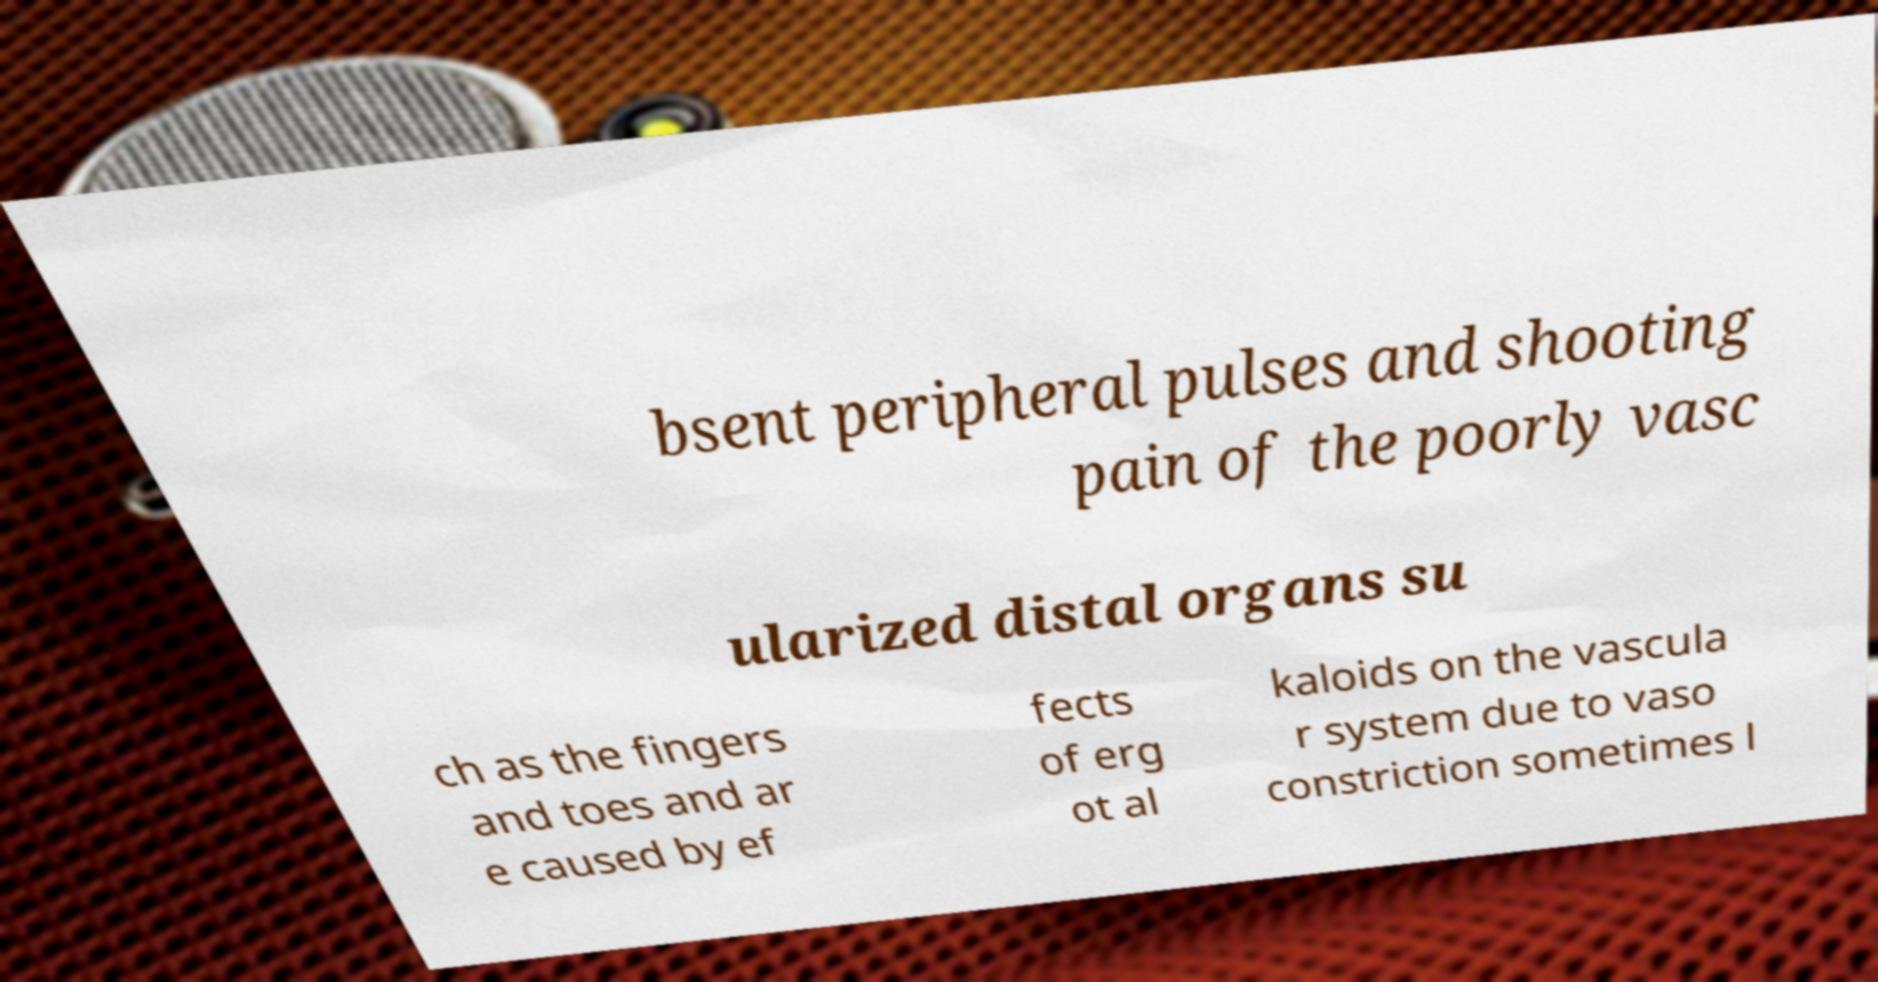Could you extract and type out the text from this image? bsent peripheral pulses and shooting pain of the poorly vasc ularized distal organs su ch as the fingers and toes and ar e caused by ef fects of erg ot al kaloids on the vascula r system due to vaso constriction sometimes l 